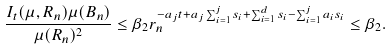Convert formula to latex. <formula><loc_0><loc_0><loc_500><loc_500>\frac { I _ { t } ( \mu , R _ { n } ) \mu ( B _ { n } ) } { \mu ( R _ { n } ) ^ { 2 } } \leq \beta _ { 2 } r _ { n } ^ { - a _ { j } t + a _ { j } \sum _ { i = 1 } ^ { j } s _ { i } + \sum _ { i = 1 } ^ { d } s _ { i } - \sum _ { i = 1 } ^ { j } a _ { i } s _ { i } } \leq \beta _ { 2 } .</formula> 